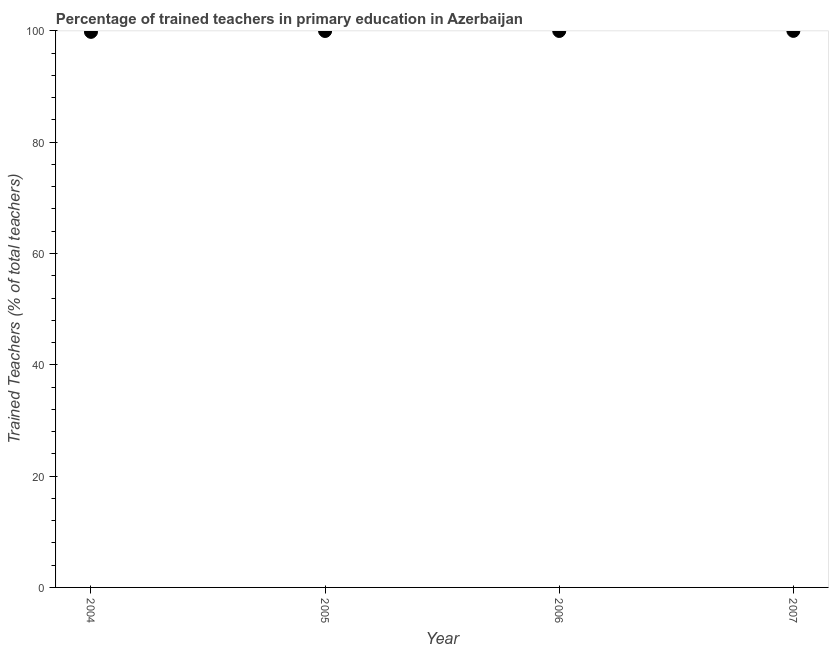What is the percentage of trained teachers in 2006?
Ensure brevity in your answer.  99.98. Across all years, what is the maximum percentage of trained teachers?
Keep it short and to the point. 100. Across all years, what is the minimum percentage of trained teachers?
Offer a very short reply. 99.82. What is the sum of the percentage of trained teachers?
Provide a short and direct response. 399.77. What is the difference between the percentage of trained teachers in 2004 and 2006?
Make the answer very short. -0.16. What is the average percentage of trained teachers per year?
Keep it short and to the point. 99.94. What is the median percentage of trained teachers?
Your response must be concise. 99.98. In how many years, is the percentage of trained teachers greater than 84 %?
Your response must be concise. 4. Do a majority of the years between 2005 and 2004 (inclusive) have percentage of trained teachers greater than 40 %?
Make the answer very short. No. What is the ratio of the percentage of trained teachers in 2005 to that in 2007?
Make the answer very short. 1. Is the percentage of trained teachers in 2004 less than that in 2007?
Your response must be concise. Yes. What is the difference between the highest and the second highest percentage of trained teachers?
Your response must be concise. 0.02. Is the sum of the percentage of trained teachers in 2005 and 2007 greater than the maximum percentage of trained teachers across all years?
Make the answer very short. Yes. What is the difference between the highest and the lowest percentage of trained teachers?
Provide a short and direct response. 0.18. In how many years, is the percentage of trained teachers greater than the average percentage of trained teachers taken over all years?
Your answer should be compact. 3. Does the percentage of trained teachers monotonically increase over the years?
Your answer should be very brief. Yes. How many dotlines are there?
Keep it short and to the point. 1. How many years are there in the graph?
Your answer should be very brief. 4. Are the values on the major ticks of Y-axis written in scientific E-notation?
Offer a terse response. No. Does the graph contain grids?
Provide a short and direct response. No. What is the title of the graph?
Offer a very short reply. Percentage of trained teachers in primary education in Azerbaijan. What is the label or title of the Y-axis?
Provide a short and direct response. Trained Teachers (% of total teachers). What is the Trained Teachers (% of total teachers) in 2004?
Ensure brevity in your answer.  99.82. What is the Trained Teachers (% of total teachers) in 2005?
Offer a terse response. 99.98. What is the Trained Teachers (% of total teachers) in 2006?
Your answer should be compact. 99.98. What is the Trained Teachers (% of total teachers) in 2007?
Provide a short and direct response. 100. What is the difference between the Trained Teachers (% of total teachers) in 2004 and 2005?
Your response must be concise. -0.16. What is the difference between the Trained Teachers (% of total teachers) in 2004 and 2006?
Give a very brief answer. -0.16. What is the difference between the Trained Teachers (% of total teachers) in 2004 and 2007?
Your answer should be very brief. -0.18. What is the difference between the Trained Teachers (% of total teachers) in 2005 and 2006?
Offer a terse response. -0.01. What is the difference between the Trained Teachers (% of total teachers) in 2005 and 2007?
Give a very brief answer. -0.02. What is the difference between the Trained Teachers (% of total teachers) in 2006 and 2007?
Your response must be concise. -0.02. What is the ratio of the Trained Teachers (% of total teachers) in 2004 to that in 2006?
Your answer should be compact. 1. What is the ratio of the Trained Teachers (% of total teachers) in 2006 to that in 2007?
Give a very brief answer. 1. 